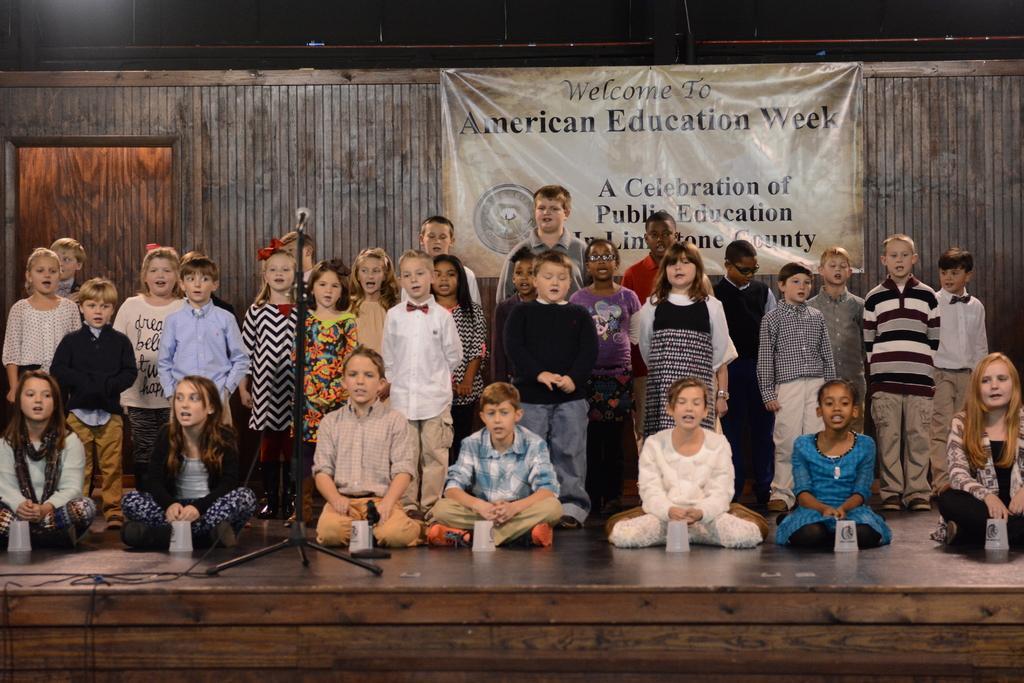How would you summarize this image in a sentence or two? In this image, there are some kids standing and there are some kids sitting, at the left side there is a black color microphone, in the background we can see a poster. 